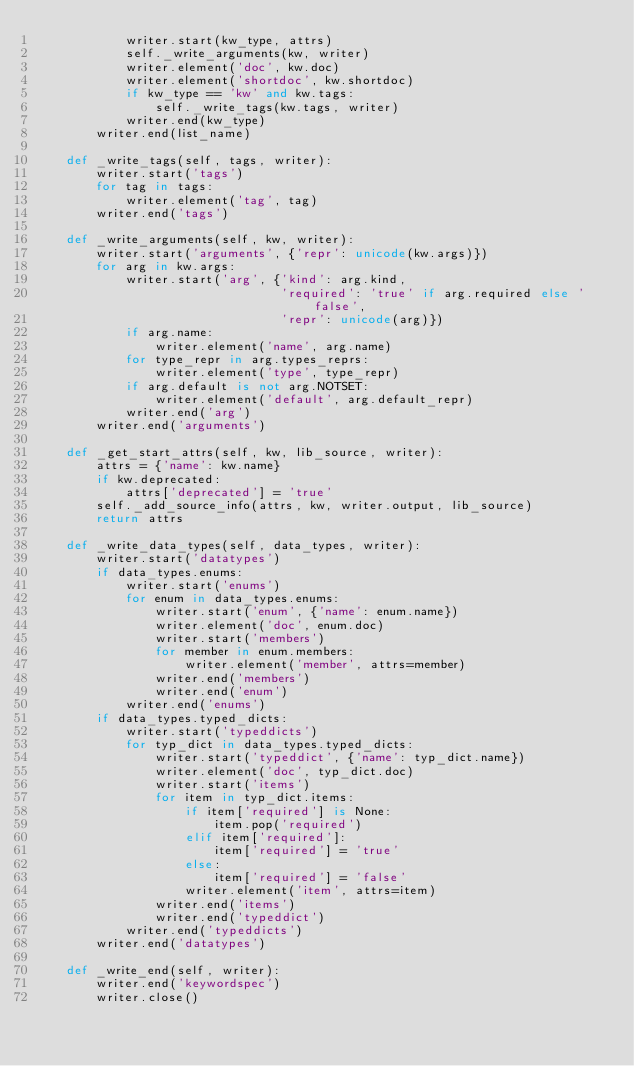<code> <loc_0><loc_0><loc_500><loc_500><_Python_>            writer.start(kw_type, attrs)
            self._write_arguments(kw, writer)
            writer.element('doc', kw.doc)
            writer.element('shortdoc', kw.shortdoc)
            if kw_type == 'kw' and kw.tags:
                self._write_tags(kw.tags, writer)
            writer.end(kw_type)
        writer.end(list_name)

    def _write_tags(self, tags, writer):
        writer.start('tags')
        for tag in tags:
            writer.element('tag', tag)
        writer.end('tags')

    def _write_arguments(self, kw, writer):
        writer.start('arguments', {'repr': unicode(kw.args)})
        for arg in kw.args:
            writer.start('arg', {'kind': arg.kind,
                                 'required': 'true' if arg.required else 'false',
                                 'repr': unicode(arg)})
            if arg.name:
                writer.element('name', arg.name)
            for type_repr in arg.types_reprs:
                writer.element('type', type_repr)
            if arg.default is not arg.NOTSET:
                writer.element('default', arg.default_repr)
            writer.end('arg')
        writer.end('arguments')

    def _get_start_attrs(self, kw, lib_source, writer):
        attrs = {'name': kw.name}
        if kw.deprecated:
            attrs['deprecated'] = 'true'
        self._add_source_info(attrs, kw, writer.output, lib_source)
        return attrs

    def _write_data_types(self, data_types, writer):
        writer.start('datatypes')
        if data_types.enums:
            writer.start('enums')
            for enum in data_types.enums:
                writer.start('enum', {'name': enum.name})
                writer.element('doc', enum.doc)
                writer.start('members')
                for member in enum.members:
                    writer.element('member', attrs=member)
                writer.end('members')
                writer.end('enum')
            writer.end('enums')
        if data_types.typed_dicts:
            writer.start('typeddicts')
            for typ_dict in data_types.typed_dicts:
                writer.start('typeddict', {'name': typ_dict.name})
                writer.element('doc', typ_dict.doc)
                writer.start('items')
                for item in typ_dict.items:
                    if item['required'] is None:
                        item.pop('required')
                    elif item['required']:
                        item['required'] = 'true'
                    else:
                        item['required'] = 'false'
                    writer.element('item', attrs=item)
                writer.end('items')
                writer.end('typeddict')
            writer.end('typeddicts')
        writer.end('datatypes')

    def _write_end(self, writer):
        writer.end('keywordspec')
        writer.close()
</code> 